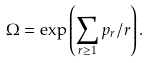Convert formula to latex. <formula><loc_0><loc_0><loc_500><loc_500>\Omega = \exp \left ( \sum _ { r \geq 1 } p _ { r } / r \right ) .</formula> 